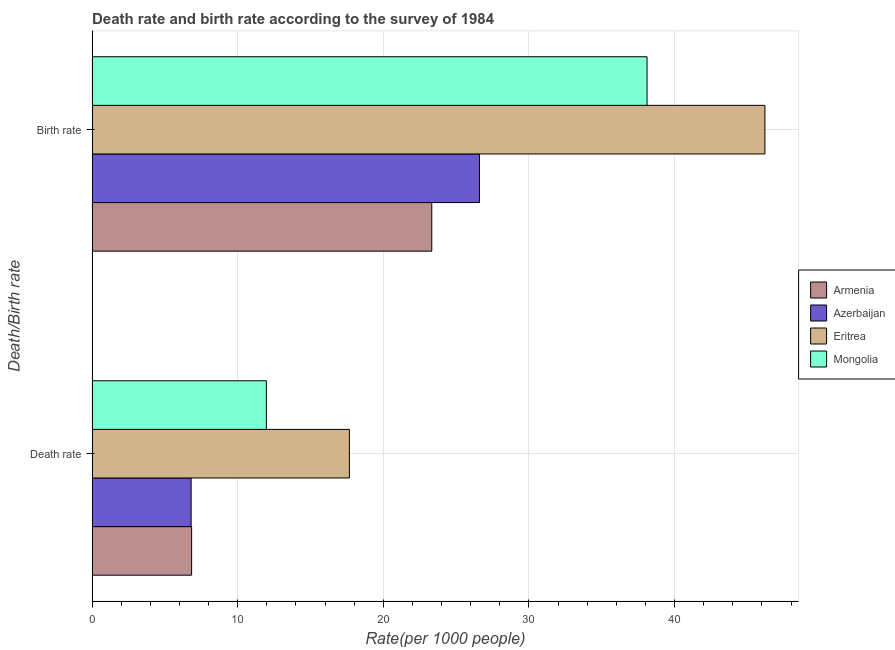How many different coloured bars are there?
Your response must be concise. 4. How many bars are there on the 2nd tick from the top?
Provide a succinct answer. 4. What is the label of the 1st group of bars from the top?
Keep it short and to the point. Birth rate. What is the death rate in Eritrea?
Give a very brief answer. 17.67. Across all countries, what is the maximum birth rate?
Keep it short and to the point. 46.2. Across all countries, what is the minimum birth rate?
Provide a succinct answer. 23.33. In which country was the death rate maximum?
Give a very brief answer. Eritrea. In which country was the death rate minimum?
Provide a short and direct response. Azerbaijan. What is the total death rate in the graph?
Ensure brevity in your answer.  43.27. What is the difference between the birth rate in Armenia and that in Azerbaijan?
Give a very brief answer. -3.27. What is the difference between the death rate in Azerbaijan and the birth rate in Mongolia?
Give a very brief answer. -31.31. What is the average death rate per country?
Keep it short and to the point. 10.82. What is the difference between the birth rate and death rate in Eritrea?
Ensure brevity in your answer.  28.54. In how many countries, is the birth rate greater than 28 ?
Your answer should be very brief. 2. What is the ratio of the death rate in Azerbaijan to that in Eritrea?
Make the answer very short. 0.38. Is the death rate in Mongolia less than that in Azerbaijan?
Your response must be concise. No. What does the 2nd bar from the top in Birth rate represents?
Your answer should be very brief. Eritrea. What does the 1st bar from the bottom in Death rate represents?
Provide a short and direct response. Armenia. How many bars are there?
Ensure brevity in your answer.  8. Are all the bars in the graph horizontal?
Your answer should be compact. Yes. Are the values on the major ticks of X-axis written in scientific E-notation?
Your answer should be very brief. No. What is the title of the graph?
Your response must be concise. Death rate and birth rate according to the survey of 1984. Does "Hungary" appear as one of the legend labels in the graph?
Make the answer very short. No. What is the label or title of the X-axis?
Your answer should be very brief. Rate(per 1000 people). What is the label or title of the Y-axis?
Your response must be concise. Death/Birth rate. What is the Rate(per 1000 people) of Armenia in Death rate?
Your response must be concise. 6.83. What is the Rate(per 1000 people) in Azerbaijan in Death rate?
Your response must be concise. 6.8. What is the Rate(per 1000 people) of Eritrea in Death rate?
Your answer should be very brief. 17.67. What is the Rate(per 1000 people) of Mongolia in Death rate?
Give a very brief answer. 11.97. What is the Rate(per 1000 people) in Armenia in Birth rate?
Offer a very short reply. 23.33. What is the Rate(per 1000 people) in Azerbaijan in Birth rate?
Provide a short and direct response. 26.6. What is the Rate(per 1000 people) in Eritrea in Birth rate?
Offer a terse response. 46.2. What is the Rate(per 1000 people) in Mongolia in Birth rate?
Ensure brevity in your answer.  38.11. Across all Death/Birth rate, what is the maximum Rate(per 1000 people) in Armenia?
Make the answer very short. 23.33. Across all Death/Birth rate, what is the maximum Rate(per 1000 people) of Azerbaijan?
Offer a terse response. 26.6. Across all Death/Birth rate, what is the maximum Rate(per 1000 people) of Eritrea?
Your answer should be compact. 46.2. Across all Death/Birth rate, what is the maximum Rate(per 1000 people) of Mongolia?
Your answer should be very brief. 38.11. Across all Death/Birth rate, what is the minimum Rate(per 1000 people) in Armenia?
Offer a terse response. 6.83. Across all Death/Birth rate, what is the minimum Rate(per 1000 people) in Azerbaijan?
Provide a short and direct response. 6.8. Across all Death/Birth rate, what is the minimum Rate(per 1000 people) in Eritrea?
Provide a succinct answer. 17.67. Across all Death/Birth rate, what is the minimum Rate(per 1000 people) of Mongolia?
Your answer should be compact. 11.97. What is the total Rate(per 1000 people) of Armenia in the graph?
Keep it short and to the point. 30.16. What is the total Rate(per 1000 people) in Azerbaijan in the graph?
Make the answer very short. 33.4. What is the total Rate(per 1000 people) in Eritrea in the graph?
Give a very brief answer. 63.87. What is the total Rate(per 1000 people) in Mongolia in the graph?
Your answer should be very brief. 50.08. What is the difference between the Rate(per 1000 people) in Armenia in Death rate and that in Birth rate?
Your answer should be compact. -16.49. What is the difference between the Rate(per 1000 people) in Azerbaijan in Death rate and that in Birth rate?
Provide a short and direct response. -19.8. What is the difference between the Rate(per 1000 people) of Eritrea in Death rate and that in Birth rate?
Offer a terse response. -28.54. What is the difference between the Rate(per 1000 people) in Mongolia in Death rate and that in Birth rate?
Provide a short and direct response. -26.14. What is the difference between the Rate(per 1000 people) in Armenia in Death rate and the Rate(per 1000 people) in Azerbaijan in Birth rate?
Your answer should be compact. -19.77. What is the difference between the Rate(per 1000 people) in Armenia in Death rate and the Rate(per 1000 people) in Eritrea in Birth rate?
Your response must be concise. -39.37. What is the difference between the Rate(per 1000 people) of Armenia in Death rate and the Rate(per 1000 people) of Mongolia in Birth rate?
Your response must be concise. -31.27. What is the difference between the Rate(per 1000 people) in Azerbaijan in Death rate and the Rate(per 1000 people) in Eritrea in Birth rate?
Give a very brief answer. -39.41. What is the difference between the Rate(per 1000 people) of Azerbaijan in Death rate and the Rate(per 1000 people) of Mongolia in Birth rate?
Keep it short and to the point. -31.31. What is the difference between the Rate(per 1000 people) of Eritrea in Death rate and the Rate(per 1000 people) of Mongolia in Birth rate?
Keep it short and to the point. -20.44. What is the average Rate(per 1000 people) in Armenia per Death/Birth rate?
Make the answer very short. 15.08. What is the average Rate(per 1000 people) of Azerbaijan per Death/Birth rate?
Make the answer very short. 16.7. What is the average Rate(per 1000 people) of Eritrea per Death/Birth rate?
Your response must be concise. 31.94. What is the average Rate(per 1000 people) of Mongolia per Death/Birth rate?
Provide a succinct answer. 25.04. What is the difference between the Rate(per 1000 people) of Armenia and Rate(per 1000 people) of Azerbaijan in Death rate?
Your answer should be compact. 0.04. What is the difference between the Rate(per 1000 people) in Armenia and Rate(per 1000 people) in Eritrea in Death rate?
Provide a short and direct response. -10.83. What is the difference between the Rate(per 1000 people) in Armenia and Rate(per 1000 people) in Mongolia in Death rate?
Your answer should be compact. -5.13. What is the difference between the Rate(per 1000 people) in Azerbaijan and Rate(per 1000 people) in Eritrea in Death rate?
Ensure brevity in your answer.  -10.87. What is the difference between the Rate(per 1000 people) of Azerbaijan and Rate(per 1000 people) of Mongolia in Death rate?
Ensure brevity in your answer.  -5.17. What is the difference between the Rate(per 1000 people) of Eritrea and Rate(per 1000 people) of Mongolia in Death rate?
Your answer should be compact. 5.7. What is the difference between the Rate(per 1000 people) in Armenia and Rate(per 1000 people) in Azerbaijan in Birth rate?
Make the answer very short. -3.27. What is the difference between the Rate(per 1000 people) in Armenia and Rate(per 1000 people) in Eritrea in Birth rate?
Provide a short and direct response. -22.88. What is the difference between the Rate(per 1000 people) in Armenia and Rate(per 1000 people) in Mongolia in Birth rate?
Ensure brevity in your answer.  -14.78. What is the difference between the Rate(per 1000 people) of Azerbaijan and Rate(per 1000 people) of Eritrea in Birth rate?
Your response must be concise. -19.61. What is the difference between the Rate(per 1000 people) in Azerbaijan and Rate(per 1000 people) in Mongolia in Birth rate?
Offer a very short reply. -11.51. What is the difference between the Rate(per 1000 people) in Eritrea and Rate(per 1000 people) in Mongolia in Birth rate?
Keep it short and to the point. 8.1. What is the ratio of the Rate(per 1000 people) of Armenia in Death rate to that in Birth rate?
Your answer should be very brief. 0.29. What is the ratio of the Rate(per 1000 people) in Azerbaijan in Death rate to that in Birth rate?
Your answer should be very brief. 0.26. What is the ratio of the Rate(per 1000 people) in Eritrea in Death rate to that in Birth rate?
Your answer should be very brief. 0.38. What is the ratio of the Rate(per 1000 people) in Mongolia in Death rate to that in Birth rate?
Give a very brief answer. 0.31. What is the difference between the highest and the second highest Rate(per 1000 people) of Armenia?
Make the answer very short. 16.49. What is the difference between the highest and the second highest Rate(per 1000 people) in Azerbaijan?
Offer a very short reply. 19.8. What is the difference between the highest and the second highest Rate(per 1000 people) in Eritrea?
Provide a short and direct response. 28.54. What is the difference between the highest and the second highest Rate(per 1000 people) in Mongolia?
Provide a short and direct response. 26.14. What is the difference between the highest and the lowest Rate(per 1000 people) in Armenia?
Offer a terse response. 16.49. What is the difference between the highest and the lowest Rate(per 1000 people) of Azerbaijan?
Provide a succinct answer. 19.8. What is the difference between the highest and the lowest Rate(per 1000 people) in Eritrea?
Offer a very short reply. 28.54. What is the difference between the highest and the lowest Rate(per 1000 people) in Mongolia?
Ensure brevity in your answer.  26.14. 